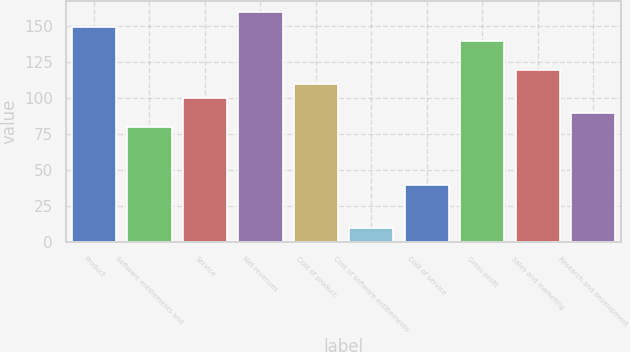Convert chart. <chart><loc_0><loc_0><loc_500><loc_500><bar_chart><fcel>Product<fcel>Software entitlements and<fcel>Service<fcel>Net revenues<fcel>Cost of product<fcel>Cost of software entitlements<fcel>Cost of service<fcel>Gross profit<fcel>Sales and marketing<fcel>Research and development<nl><fcel>149.95<fcel>80.02<fcel>100<fcel>159.94<fcel>109.99<fcel>10.09<fcel>40.06<fcel>139.96<fcel>119.98<fcel>90.01<nl></chart> 